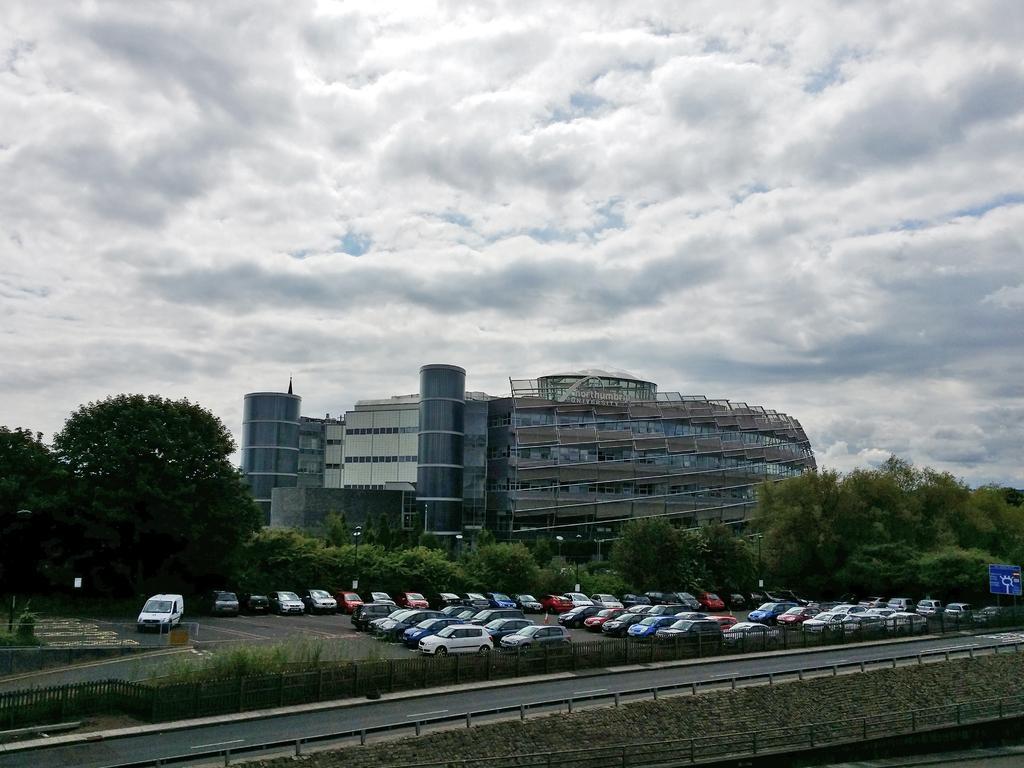Can you describe this image briefly? In this image I can see at the bottom there is the road, in the middle many cars are parked and there are trees, at the back side there is a very big building. At the top it is the cloudy sky. 